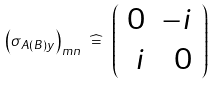Convert formula to latex. <formula><loc_0><loc_0><loc_500><loc_500>\left ( \sigma _ { A ( B ) y } \right ) _ { m n } \ \widehat { = } \ \left ( \begin{array} { r r } 0 & - i \\ i & 0 \end{array} \right )</formula> 